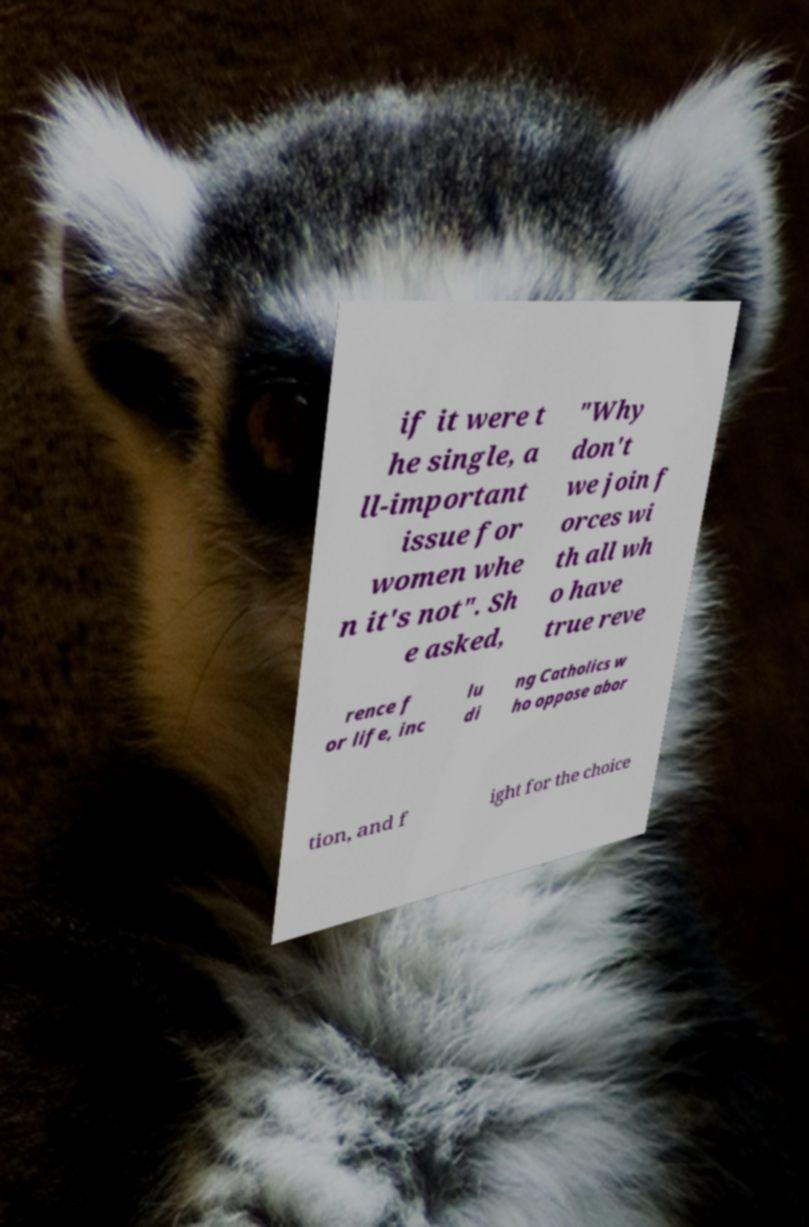Please read and relay the text visible in this image. What does it say? if it were t he single, a ll-important issue for women whe n it's not". Sh e asked, "Why don't we join f orces wi th all wh o have true reve rence f or life, inc lu di ng Catholics w ho oppose abor tion, and f ight for the choice 